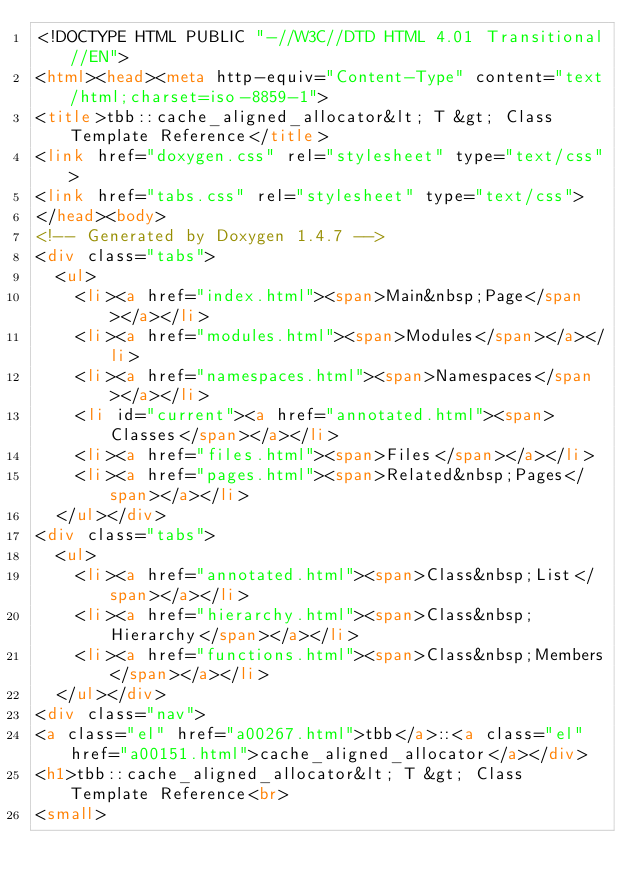<code> <loc_0><loc_0><loc_500><loc_500><_HTML_><!DOCTYPE HTML PUBLIC "-//W3C//DTD HTML 4.01 Transitional//EN">
<html><head><meta http-equiv="Content-Type" content="text/html;charset=iso-8859-1">
<title>tbb::cache_aligned_allocator&lt; T &gt; Class Template Reference</title>
<link href="doxygen.css" rel="stylesheet" type="text/css">
<link href="tabs.css" rel="stylesheet" type="text/css">
</head><body>
<!-- Generated by Doxygen 1.4.7 -->
<div class="tabs">
  <ul>
    <li><a href="index.html"><span>Main&nbsp;Page</span></a></li>
    <li><a href="modules.html"><span>Modules</span></a></li>
    <li><a href="namespaces.html"><span>Namespaces</span></a></li>
    <li id="current"><a href="annotated.html"><span>Classes</span></a></li>
    <li><a href="files.html"><span>Files</span></a></li>
    <li><a href="pages.html"><span>Related&nbsp;Pages</span></a></li>
  </ul></div>
<div class="tabs">
  <ul>
    <li><a href="annotated.html"><span>Class&nbsp;List</span></a></li>
    <li><a href="hierarchy.html"><span>Class&nbsp;Hierarchy</span></a></li>
    <li><a href="functions.html"><span>Class&nbsp;Members</span></a></li>
  </ul></div>
<div class="nav">
<a class="el" href="a00267.html">tbb</a>::<a class="el" href="a00151.html">cache_aligned_allocator</a></div>
<h1>tbb::cache_aligned_allocator&lt; T &gt; Class Template Reference<br>
<small></code> 